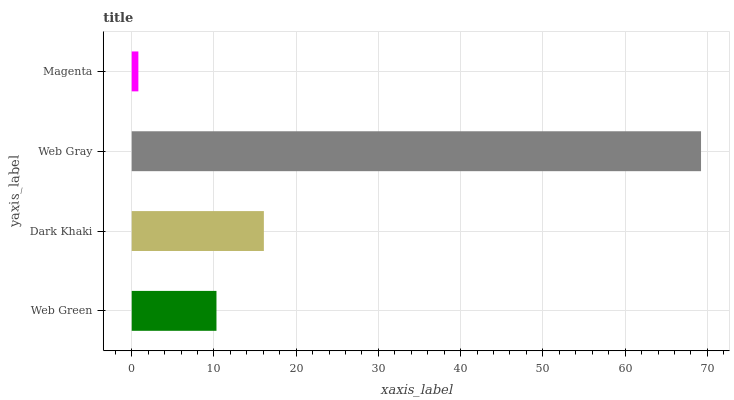Is Magenta the minimum?
Answer yes or no. Yes. Is Web Gray the maximum?
Answer yes or no. Yes. Is Dark Khaki the minimum?
Answer yes or no. No. Is Dark Khaki the maximum?
Answer yes or no. No. Is Dark Khaki greater than Web Green?
Answer yes or no. Yes. Is Web Green less than Dark Khaki?
Answer yes or no. Yes. Is Web Green greater than Dark Khaki?
Answer yes or no. No. Is Dark Khaki less than Web Green?
Answer yes or no. No. Is Dark Khaki the high median?
Answer yes or no. Yes. Is Web Green the low median?
Answer yes or no. Yes. Is Magenta the high median?
Answer yes or no. No. Is Magenta the low median?
Answer yes or no. No. 